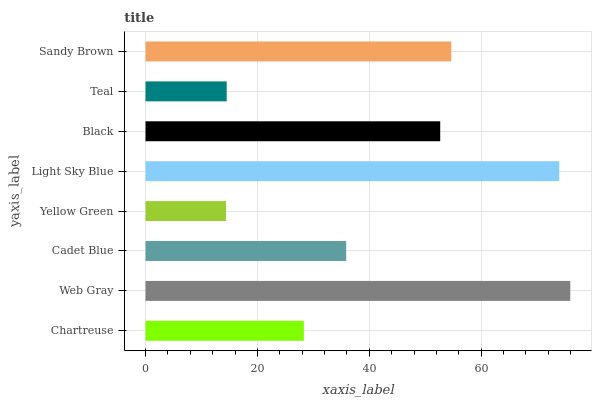Is Yellow Green the minimum?
Answer yes or no. Yes. Is Web Gray the maximum?
Answer yes or no. Yes. Is Cadet Blue the minimum?
Answer yes or no. No. Is Cadet Blue the maximum?
Answer yes or no. No. Is Web Gray greater than Cadet Blue?
Answer yes or no. Yes. Is Cadet Blue less than Web Gray?
Answer yes or no. Yes. Is Cadet Blue greater than Web Gray?
Answer yes or no. No. Is Web Gray less than Cadet Blue?
Answer yes or no. No. Is Black the high median?
Answer yes or no. Yes. Is Cadet Blue the low median?
Answer yes or no. Yes. Is Teal the high median?
Answer yes or no. No. Is Light Sky Blue the low median?
Answer yes or no. No. 